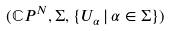Convert formula to latex. <formula><loc_0><loc_0><loc_500><loc_500>( \mathbb { C } P ^ { N } , \Sigma , \{ U _ { \alpha } \, | \, \alpha \in \Sigma \} )</formula> 